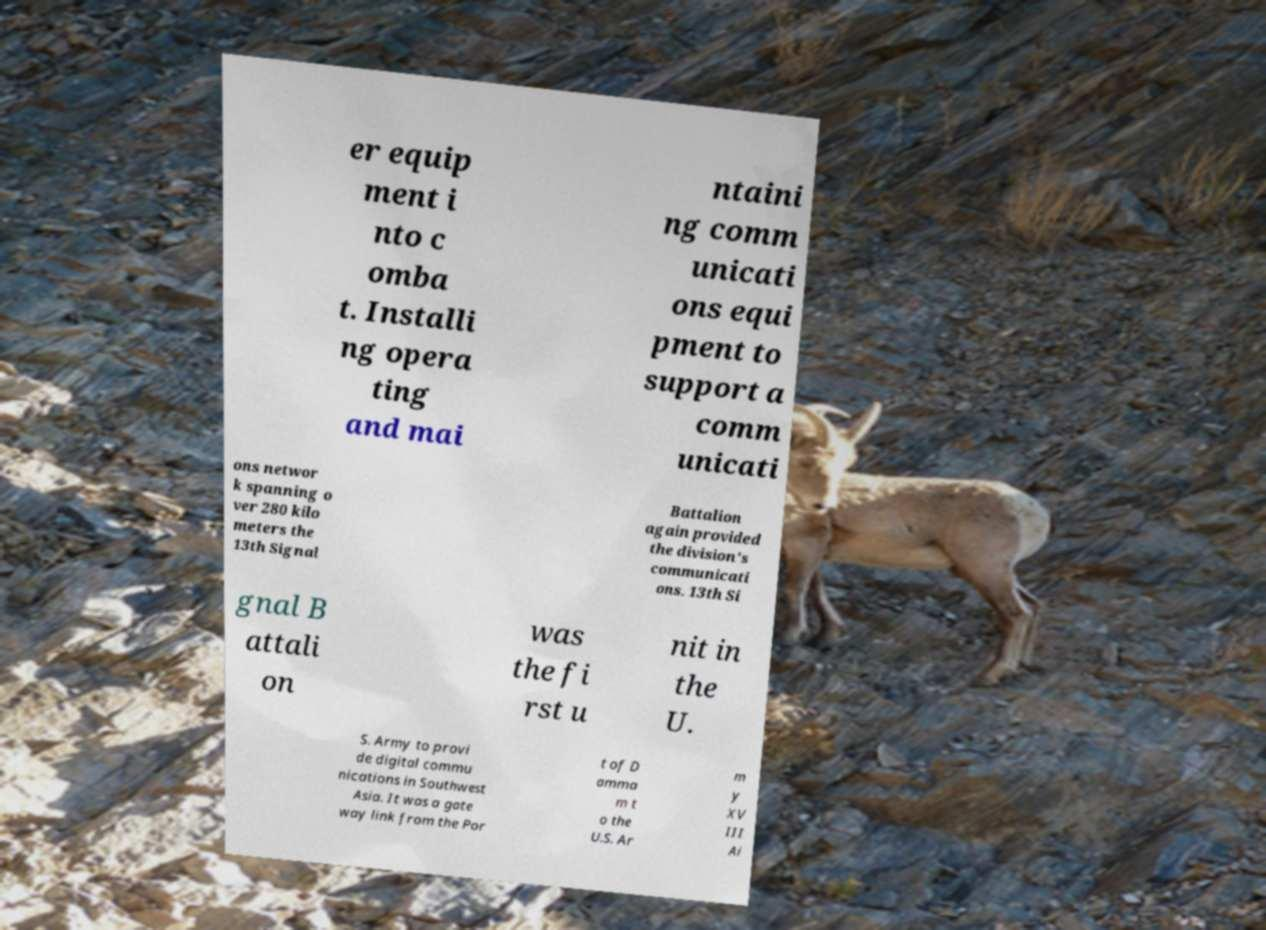There's text embedded in this image that I need extracted. Can you transcribe it verbatim? er equip ment i nto c omba t. Installi ng opera ting and mai ntaini ng comm unicati ons equi pment to support a comm unicati ons networ k spanning o ver 280 kilo meters the 13th Signal Battalion again provided the division's communicati ons. 13th Si gnal B attali on was the fi rst u nit in the U. S. Army to provi de digital commu nications in Southwest Asia. It was a gate way link from the Por t of D amma m t o the U.S. Ar m y XV III Ai 